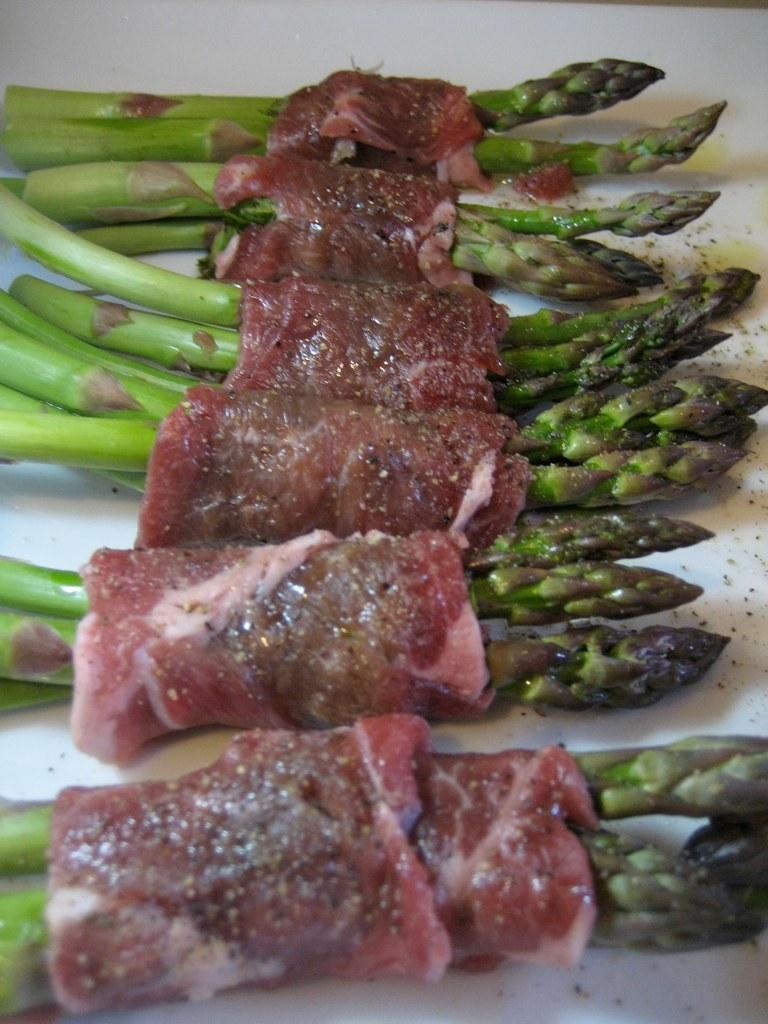What is placed on the table in the image? There is food placed on a table in the image. What type of shoe can be seen on the table in the image? There is no shoe present on the table in the image. Is there a dock visible in the image? There is no dock present in the image. 